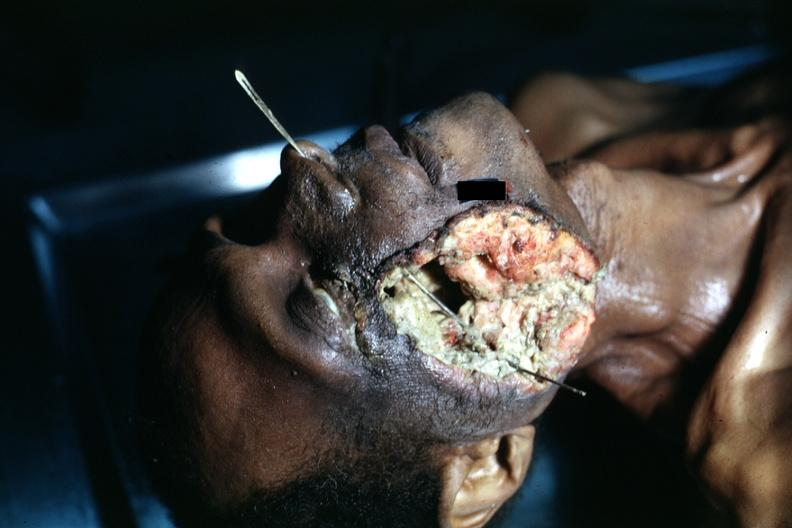what is present?
Answer the question using a single word or phrase. Squamous cell carcinoma 